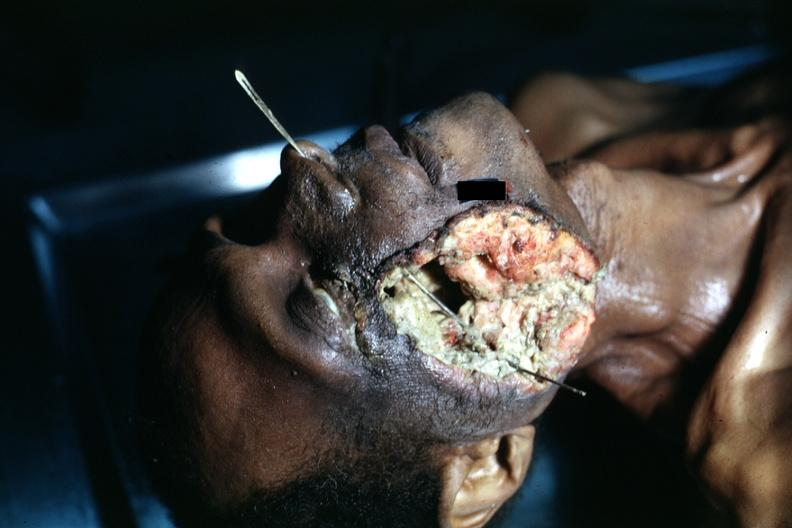what is present?
Answer the question using a single word or phrase. Squamous cell carcinoma 